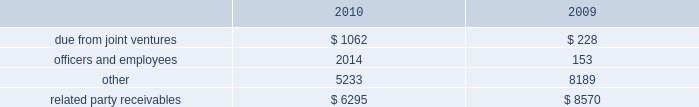Amounts due from related parties at december a031 , 2010 and 2009 con- sisted of the following ( in thousands ) : .
Gramercy capital corp .
See note a0 6 , 201cinvestment in unconsolidated joint ventures 2014gramercy capital corp. , 201d for disclosure on related party transactions between gramercy and the company .
13 2002equit y common stock our authorized capital stock consists of 260000000 shares , $ .01 par value , of which we have authorized the issuance of up to 160000000 shares of common stock , $ .01 par value per share , 75000000 shares of excess stock , $ .01 par value per share , and 25000000 shares of preferred stock , $ .01 par value per share .
As of december a031 , 2010 , 78306702 shares of common stock and no shares of excess stock were issued and outstanding .
In may 2009 , we sold 19550000 shares of our common stock at a gross price of $ 20.75 per share .
The net proceeds from this offer- ing ( approximately $ 387.1 a0 million ) were primarily used to repurchase unsecured debt .
Perpetual preferred stock in january 2010 , we sold 5400000 shares of our series a0c preferred stock in an underwritten public offering .
As a result of this offering , we have 11700000 shares of the series a0 c preferred stock outstanding .
The shares of series a0c preferred stock have a liquidation preference of $ 25.00 per share and are redeemable at par , plus accrued and unpaid dividends , at any time at our option .
The shares were priced at $ 23.53 per share including accrued dividends equating to a yield of 8.101% ( 8.101 % ) .
We used the net offering proceeds of approximately $ 122.0 a0million for gen- eral corporate and/or working capital purposes , including purchases of the indebtedness of our subsidiaries and investment opportunities .
In december 2003 , we sold 6300000 shares of our 7.625% ( 7.625 % ) series a0 c preferred stock , ( including the underwriters 2019 over-allotment option of 700000 shares ) with a mandatory liquidation preference of $ 25.00 per share .
Net proceeds from this offering ( approximately $ 152.0 a0 million ) were used principally to repay amounts outstanding under our secured and unsecured revolving credit facilities .
The series a0c preferred stockholders receive annual dividends of $ 1.90625 per share paid on a quarterly basis and dividends are cumulative , subject to cer- tain provisions .
Since december a0 12 , 2008 , we have been entitled to redeem the series a0c preferred stock at par for cash at our option .
The series a0c preferred stock was recorded net of underwriters discount and issuance costs .
12 2002related part y transactions cleaning/securit y/messenger and restoration services through al l iance bui lding services , or al l iance , first qual i t y maintenance , a0l.p. , or first quality , provides cleaning , extermination and related services , classic security a0llc provides security services , bright star couriers a0llc provides messenger services , and onyx restoration works provides restoration services with respect to certain proper- ties owned by us .
Alliance is partially owned by gary green , a son of stephen a0l .
Green , the chairman of our board of directors .
In addition , first quality has the non-exclusive opportunity to provide cleaning and related services to individual tenants at our properties on a basis sepa- rately negotiated with any tenant seeking such additional services .
The service corp .
Has entered into an arrangement with alliance whereby it will receive a profit participation above a certain threshold for services provided by alliance to certain tenants at certain buildings above the base services specified in their lease agreements .
Alliance paid the service corporation approximately $ 2.2 a0million , $ 1.8 a0million and $ 1.4 a0million for the years ended december a031 , 2010 , 2009 and 2008 , respectively .
We paid alliance approximately $ 14.2 a0million , $ 14.9 a0million and $ 15.1 a0million for three years ended december a031 , 2010 , respectively , for these ser- vices ( excluding services provided directly to tenants ) .
Leases nancy peck and company leases 1003 square feet of space at 420 lexington avenue under a lease that ends in august 2015 .
Nancy peck and company is owned by nancy peck , the wife of stephen a0l .
Green .
The rent due pursuant to the lease is $ 35516 per annum for year one increas- ing to $ 40000 in year seven .
From february 2007 through december 2008 , nancy peck and company leased 507 square feet of space at 420 a0 lexington avenue pursuant to a lease which provided for annual rental payments of approximately $ 15210 .
Brokerage services cushman a0 & wakefield sonnenblick-goldman , a0 llc , or sonnenblick , a nationally recognized real estate investment banking firm , provided mortgage brokerage services to us .
Mr . a0 morton holliday , the father of mr . a0 marc holliday , was a managing director of sonnenblick at the time of the financings .
In 2009 , we paid approximately $ 428000 to sonnenblick in connection with the purchase of a sub-leasehold interest and the refinancing of 420 lexington avenue .
Management fees s.l .
Green management corp. , a consolidated entity , receives property management fees from an entity in which stephen a0l .
Green owns an inter- est .
The aggregate amount of fees paid to s.l .
Green management corp .
From such entity was approximately $ 390700 in 2010 , $ 351700 in 2009 and $ 353500 in 2008 .
Notes to consolidated financial statements .
What was the average related party receivables from 2009 to 2010? 
Computations: (((6295 + 8570) + 2) / 2)
Answer: 7433.5. 